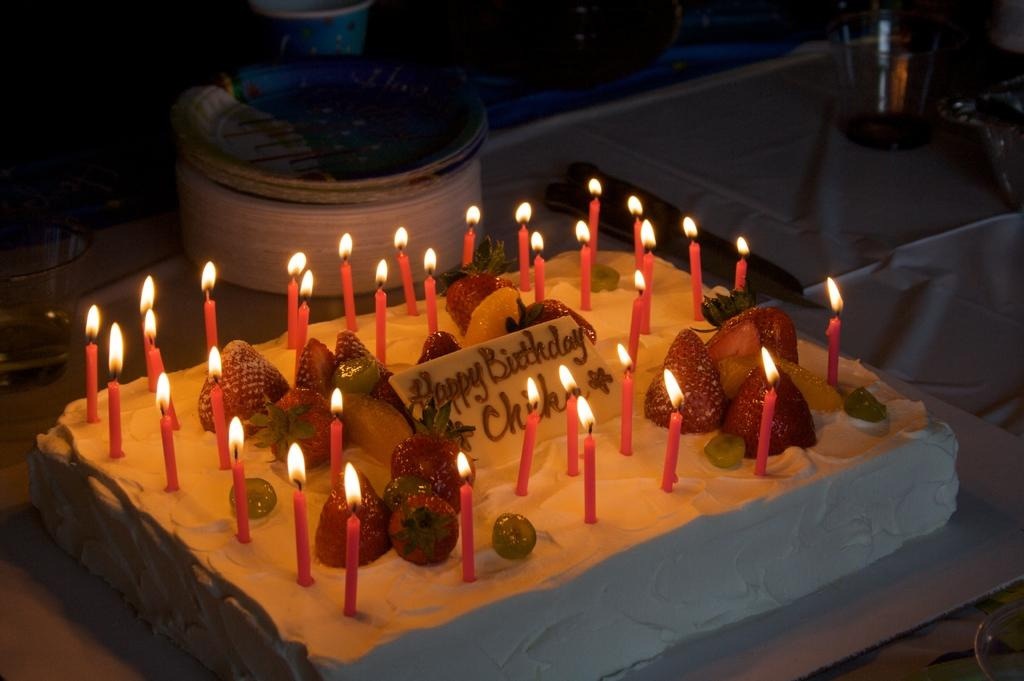What can be seen in the image that is used for lighting? There is a group of candles in the image. What is on top of the cake in the image? There are fruits on a cake in the image. Where is the cake located in the image? The cake is placed on a table. What other items can be seen in the background of the image? There is a bowl, a group of plates, and glasses in the background of the image. Can you hear the bell ringing in the image? There is no bell present in the image, so it cannot be heard. Is there a train visible in the image? There is no train present in the image. Can you see a lake in the image? There is no lake present in the image. 